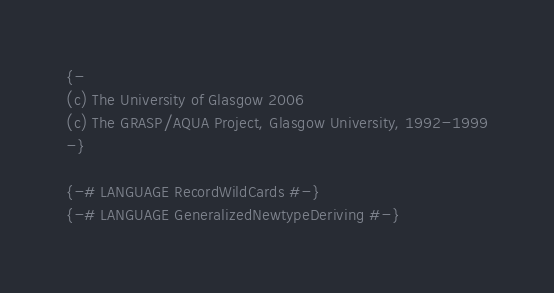Convert code to text. <code><loc_0><loc_0><loc_500><loc_500><_Haskell_>{-
(c) The University of Glasgow 2006
(c) The GRASP/AQUA Project, Glasgow University, 1992-1999
-}

{-# LANGUAGE RecordWildCards #-}
{-# LANGUAGE GeneralizedNewtypeDeriving #-}
</code> 